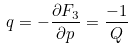Convert formula to latex. <formula><loc_0><loc_0><loc_500><loc_500>q = - \frac { \partial F _ { 3 } } { \partial p } = \frac { - 1 } { Q }</formula> 